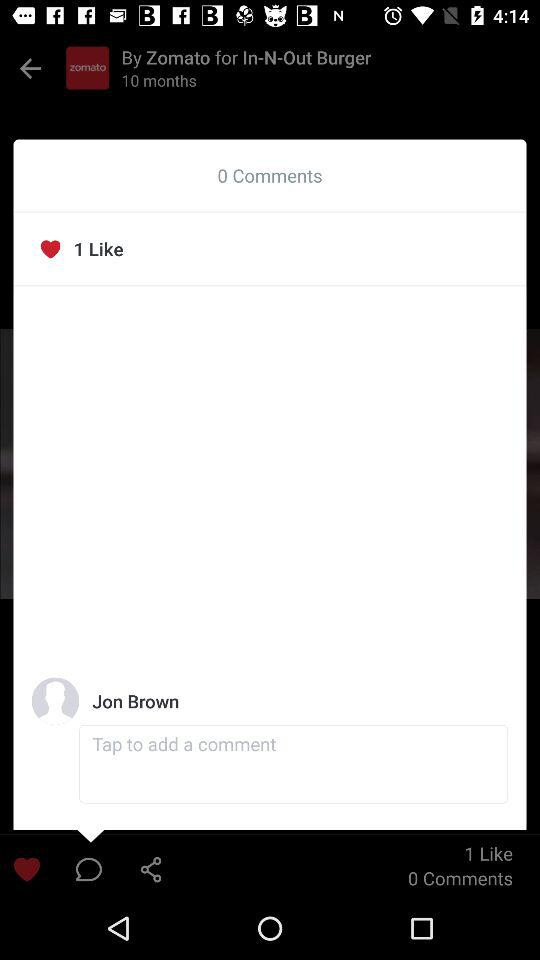How many likes are shown? There is 1 like shown. 